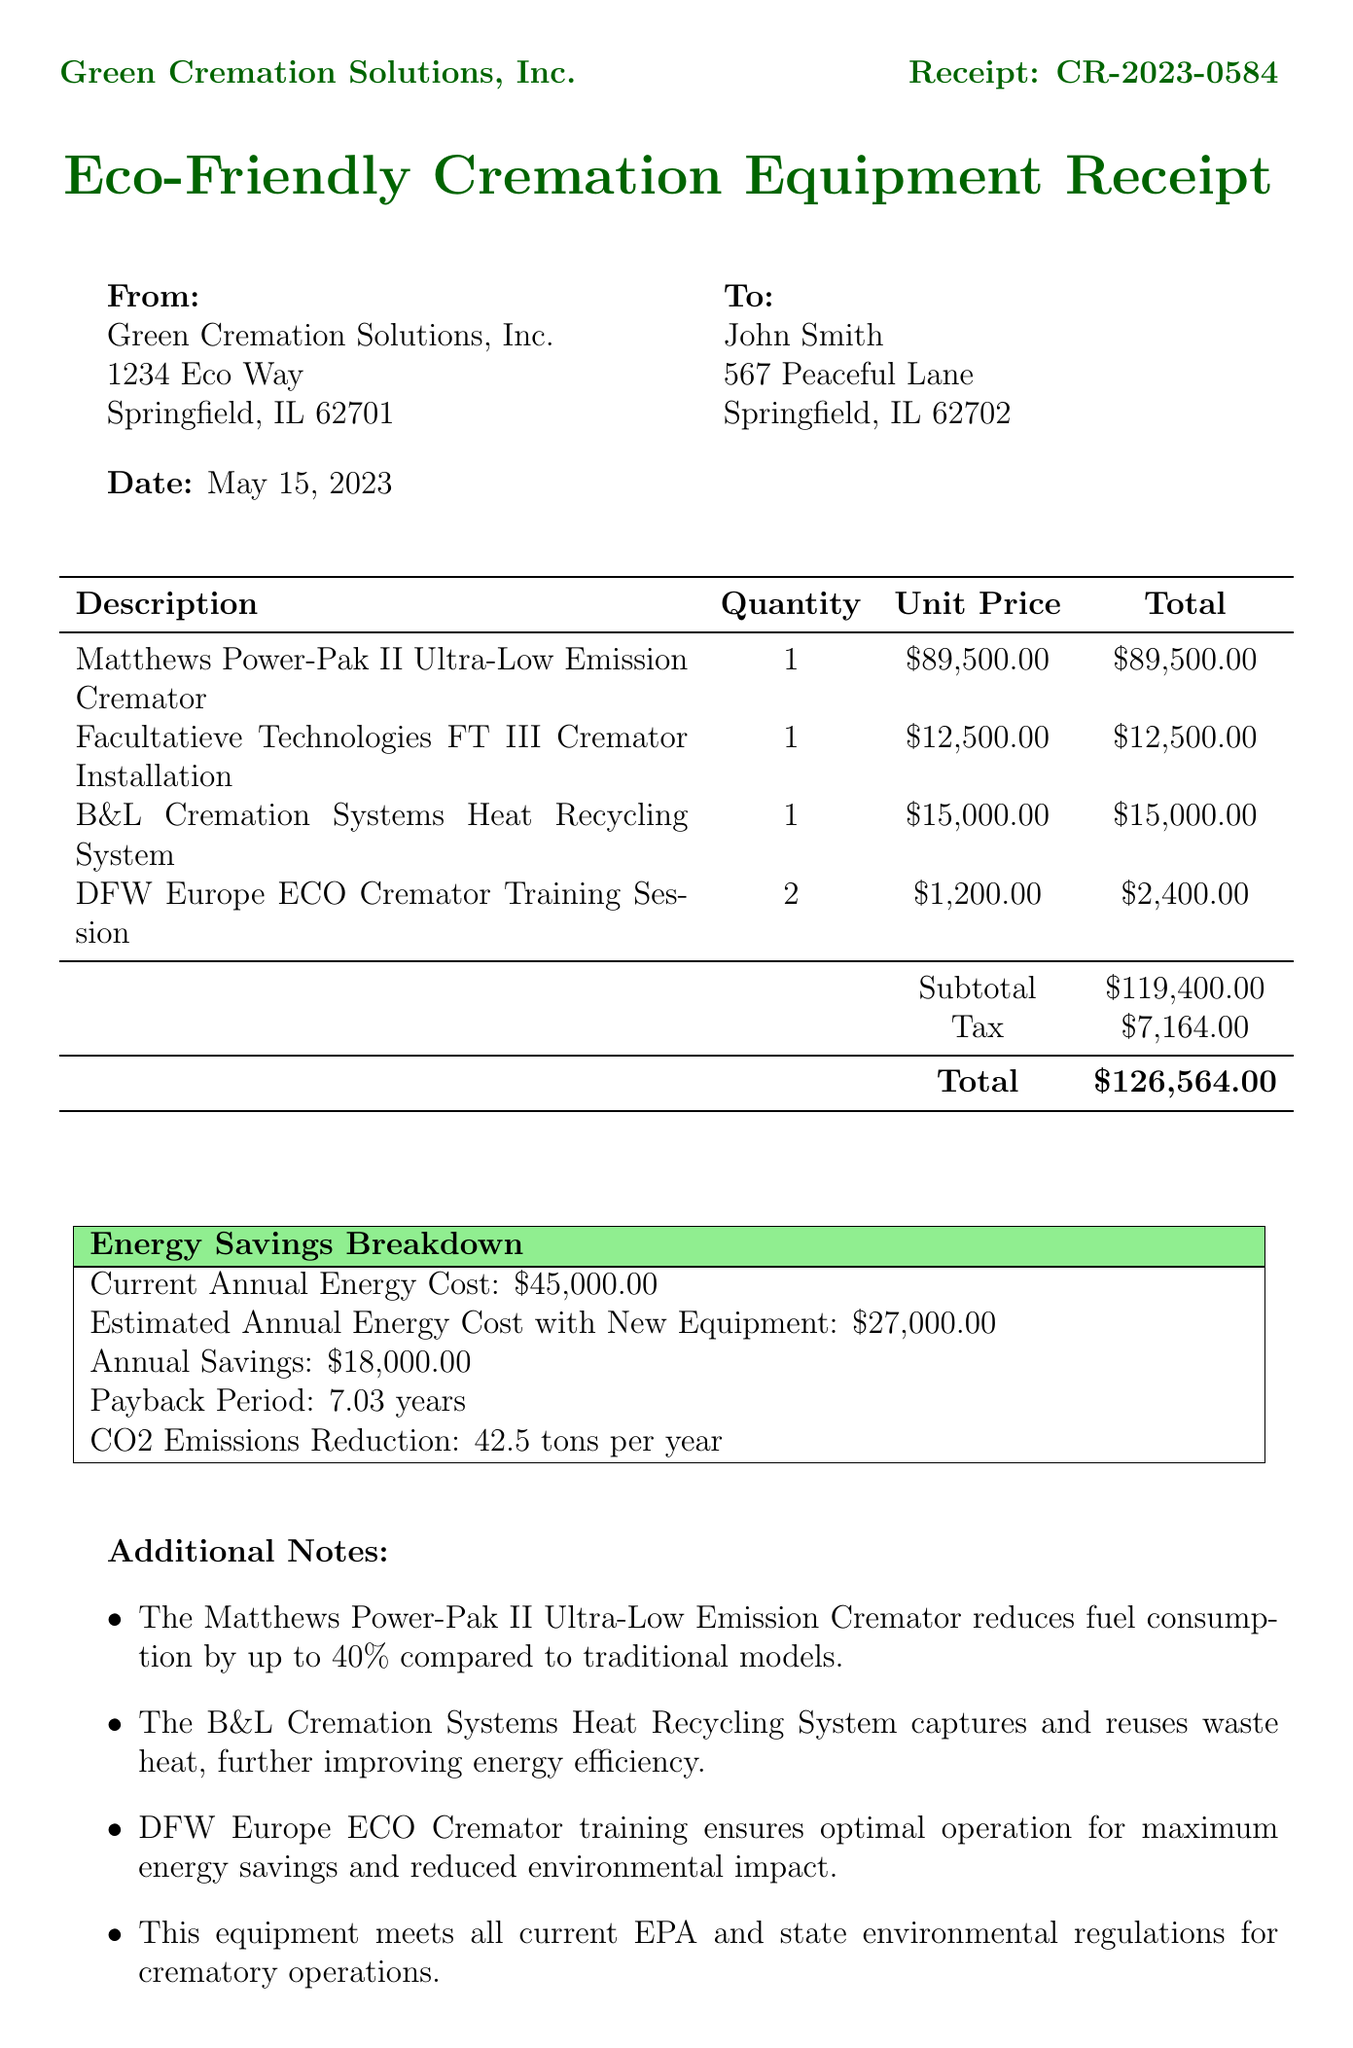What is the receipt number? The receipt number is listed at the top of the document under the title.
Answer: CR-2023-0584 Who is the customer? The customer's name and address are provided in the receipt.
Answer: John Smith What is the total amount of the receipt? The total is indicated at the bottom of the itemized list in the document.
Answer: $126,564.00 How much does the Matthews Power-Pak II Ultra-Low Emission Cremator cost? The unit price for the cremator is shown in the item list.
Answer: $89,500.00 What are the estimated annual energy costs with the new equipment? The document provides this information in the energy savings breakdown section.
Answer: $27,000.00 What is the payback period for the new equipment? This detail is mentioned in the energy savings breakdown section.
Answer: 7.03 years How much CO2 emissions reduction is expected per year? This figure is provided in the energy savings breakdown section.
Answer: 42.5 tons per year What is the warranty duration for major components? The warranty information is mentioned towards the end of the document.
Answer: 5-year limited warranty What training sessions were purchased? The item list includes specific training sessions included in the purchase.
Answer: DFW Europe ECO Cremator Training Session 